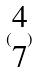<formula> <loc_0><loc_0><loc_500><loc_500>( \begin{matrix} 4 \\ 7 \end{matrix} )</formula> 